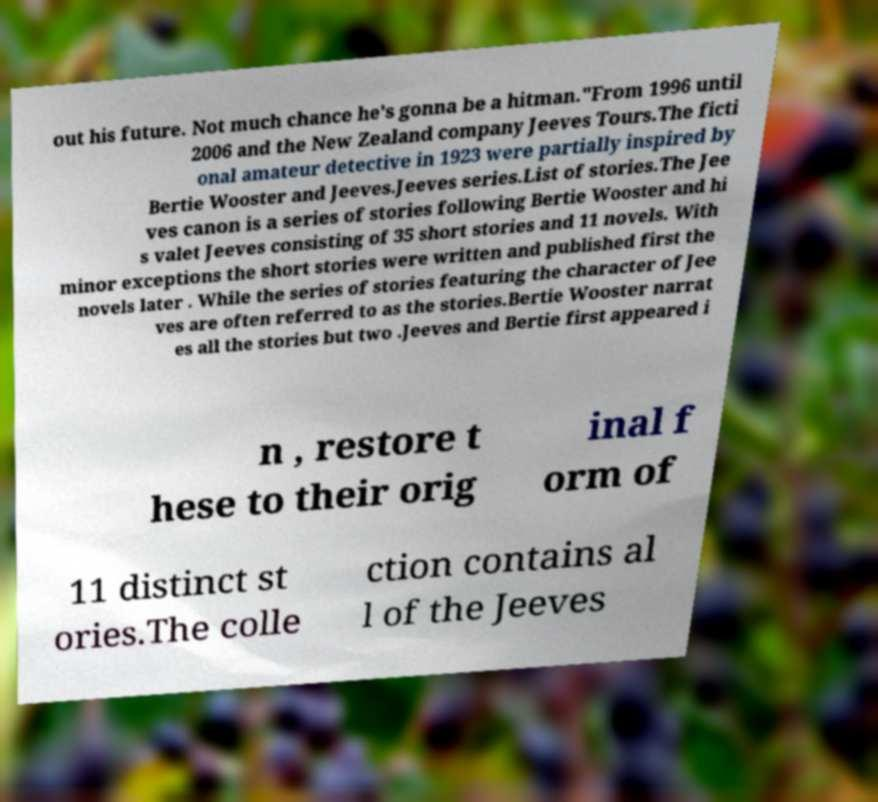There's text embedded in this image that I need extracted. Can you transcribe it verbatim? out his future. Not much chance he's gonna be a hitman."From 1996 until 2006 and the New Zealand company Jeeves Tours.The ficti onal amateur detective in 1923 were partially inspired by Bertie Wooster and Jeeves.Jeeves series.List of stories.The Jee ves canon is a series of stories following Bertie Wooster and hi s valet Jeeves consisting of 35 short stories and 11 novels. With minor exceptions the short stories were written and published first the novels later . While the series of stories featuring the character of Jee ves are often referred to as the stories.Bertie Wooster narrat es all the stories but two .Jeeves and Bertie first appeared i n , restore t hese to their orig inal f orm of 11 distinct st ories.The colle ction contains al l of the Jeeves 